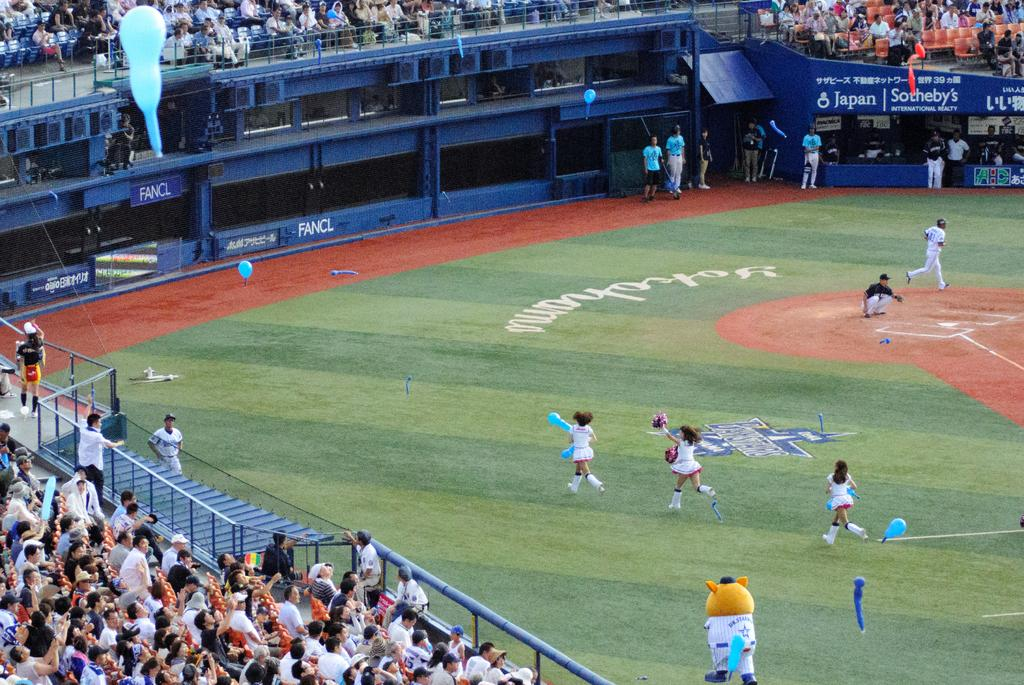<image>
Summarize the visual content of the image. An advertisement in the back is for the Sothebys auction company 